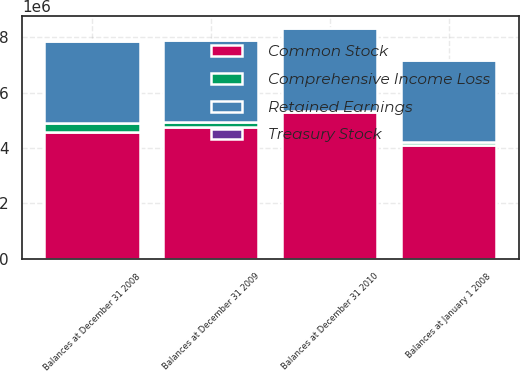Convert chart to OTSL. <chart><loc_0><loc_0><loc_500><loc_500><stacked_bar_chart><ecel><fcel>Balances at January 1 2008<fcel>Balances at December 31 2008<fcel>Balances at December 31 2009<fcel>Balances at December 31 2010<nl><fcel>Treasury Stock<fcel>2235<fcel>2239<fcel>2243<fcel>2262<nl><fcel>Retained Earnings<fcel>2.94294e+06<fcel>2.95254e+06<fcel>2.9735e+06<fcel>3.02713e+06<nl><fcel>Common Stock<fcel>4.11488e+06<fcel>4.59253e+06<fcel>4.75495e+06<fcel>5.30175e+06<nl><fcel>Comprehensive Income Loss<fcel>120955<fcel>319936<fcel>182733<fcel>25066<nl></chart> 